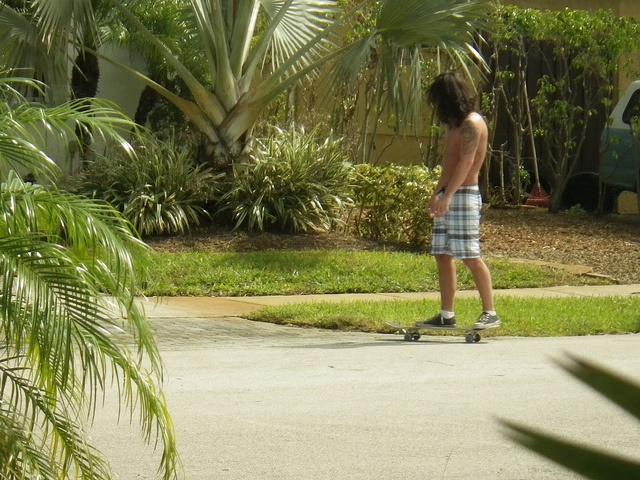Describe the objects in this image and their specific colors. I can see people in darkgreen, maroon, black, and gray tones, truck in darkgreen, black, and gray tones, and skateboard in darkgreen, olive, gray, and black tones in this image. 